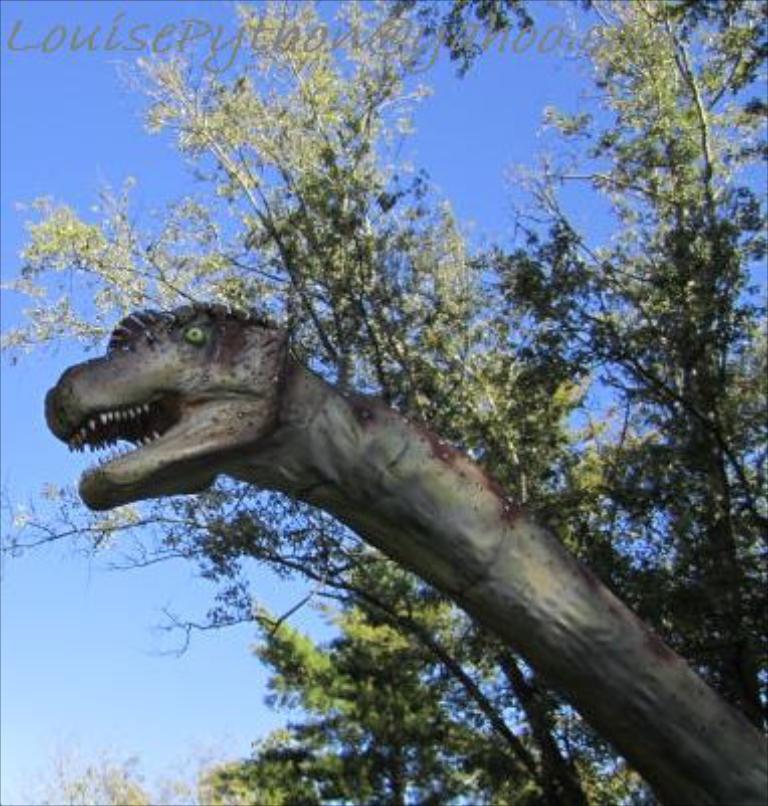Please provide a concise description of this image. In the picture we can see a sculpture of a dinosaur and behind it, we can see some trees and behind it we can see a sky. 